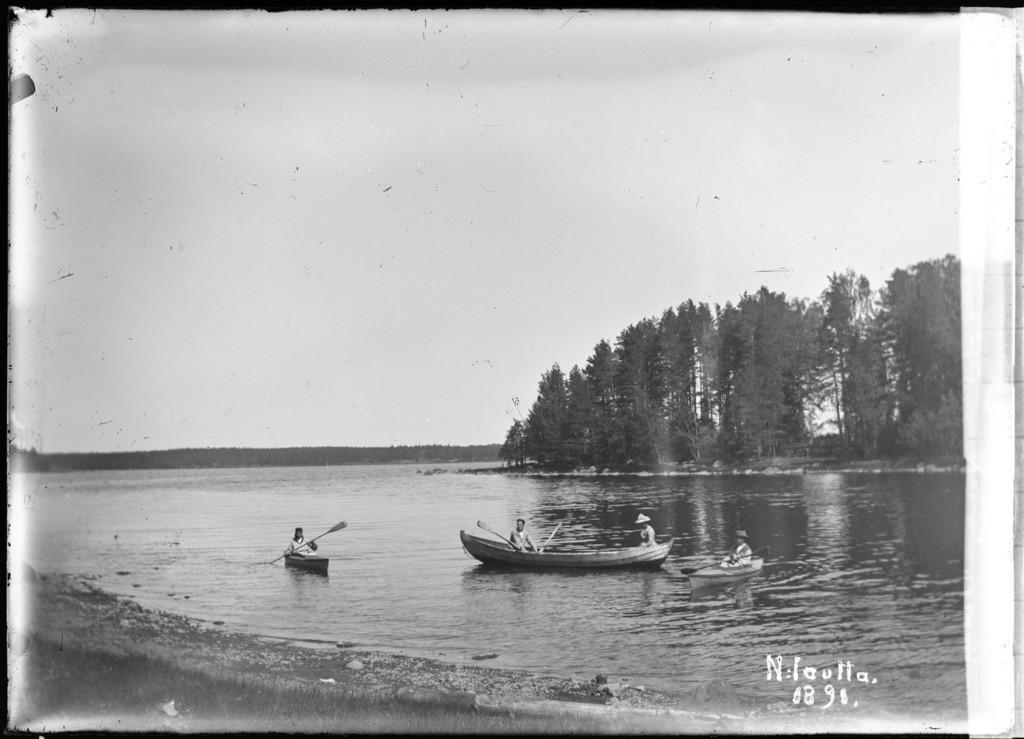Describe this image in one or two sentences. I see this is a black and white image and I see 3 boats over here on which there are persons and these 3 are holding paddles in their hands and I see the water and the ground over here. In the background I see the trees and I see the sky and I can also see a watermark over here. 